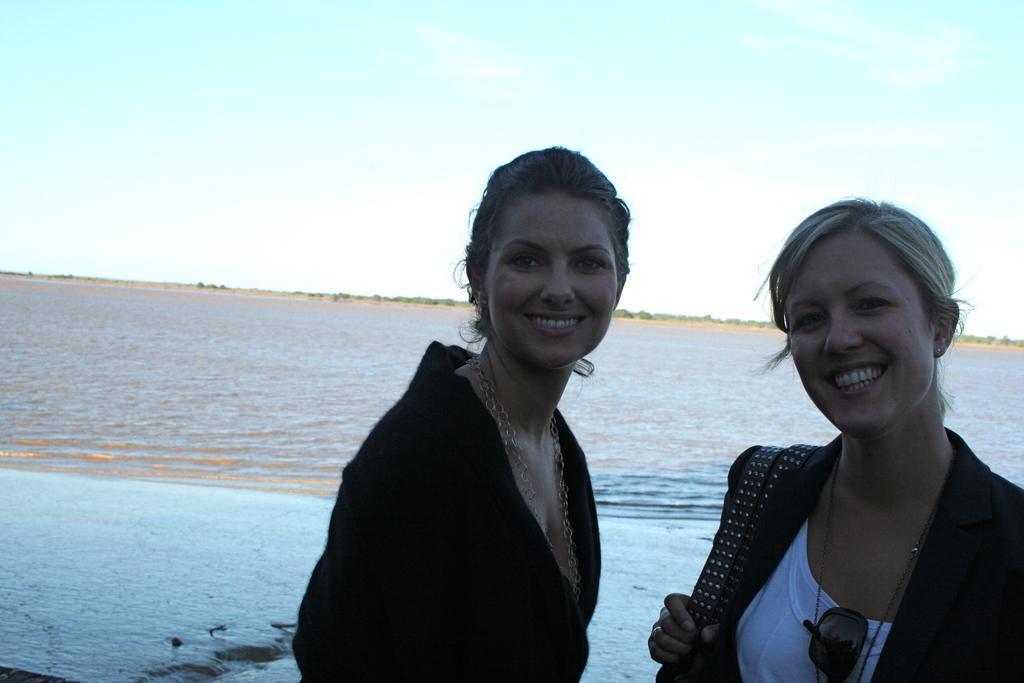Please provide a concise description of this image. In this image I can see two women. In the background, I can see water and clouds in the sky. 